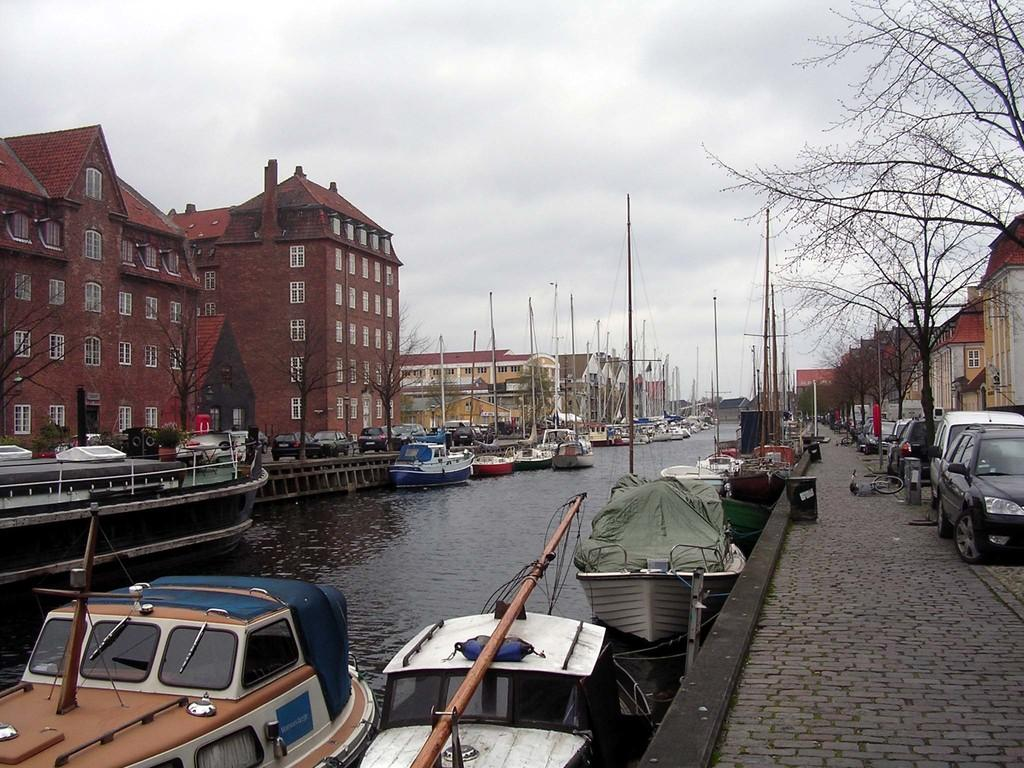What type of transportation can be seen on the water in the image? There are boats on the water in the image. What type of transportation can be seen on the roads in the image? There are vehicles on the roads in the image. What type of structures are visible in the image? There are buildings with windows in the image. What type of vegetation is present in front of the buildings? Trees are present in front of the buildings in the image. What is the condition of the sky in the image? The sky is cloudy in the image. Can you hear the boat making any noise in the image? The image is silent, so we cannot hear any noise, including the boat. What type of flooring is visible in the image? The image does not show any flooring, as it primarily focuses on outdoor elements such as boats, vehicles, buildings, trees, and the sky. 